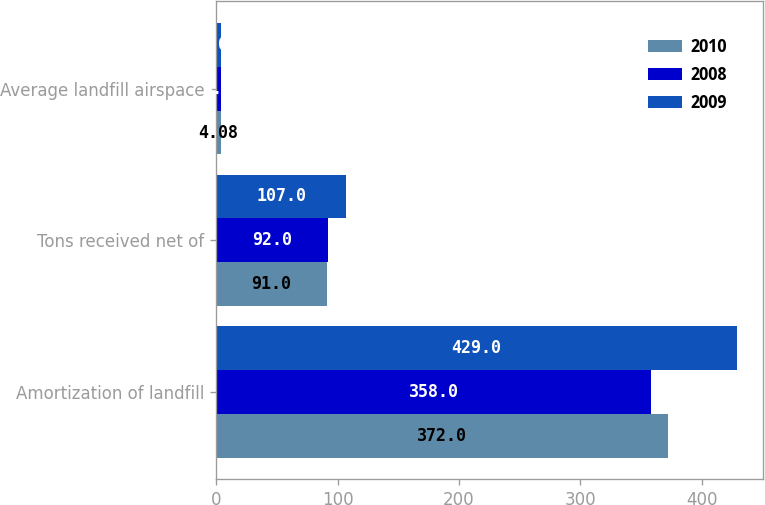Convert chart. <chart><loc_0><loc_0><loc_500><loc_500><stacked_bar_chart><ecel><fcel>Amortization of landfill<fcel>Tons received net of<fcel>Average landfill airspace<nl><fcel>2010<fcel>372<fcel>91<fcel>4.08<nl><fcel>2008<fcel>358<fcel>92<fcel>3.9<nl><fcel>2009<fcel>429<fcel>107<fcel>4.01<nl></chart> 